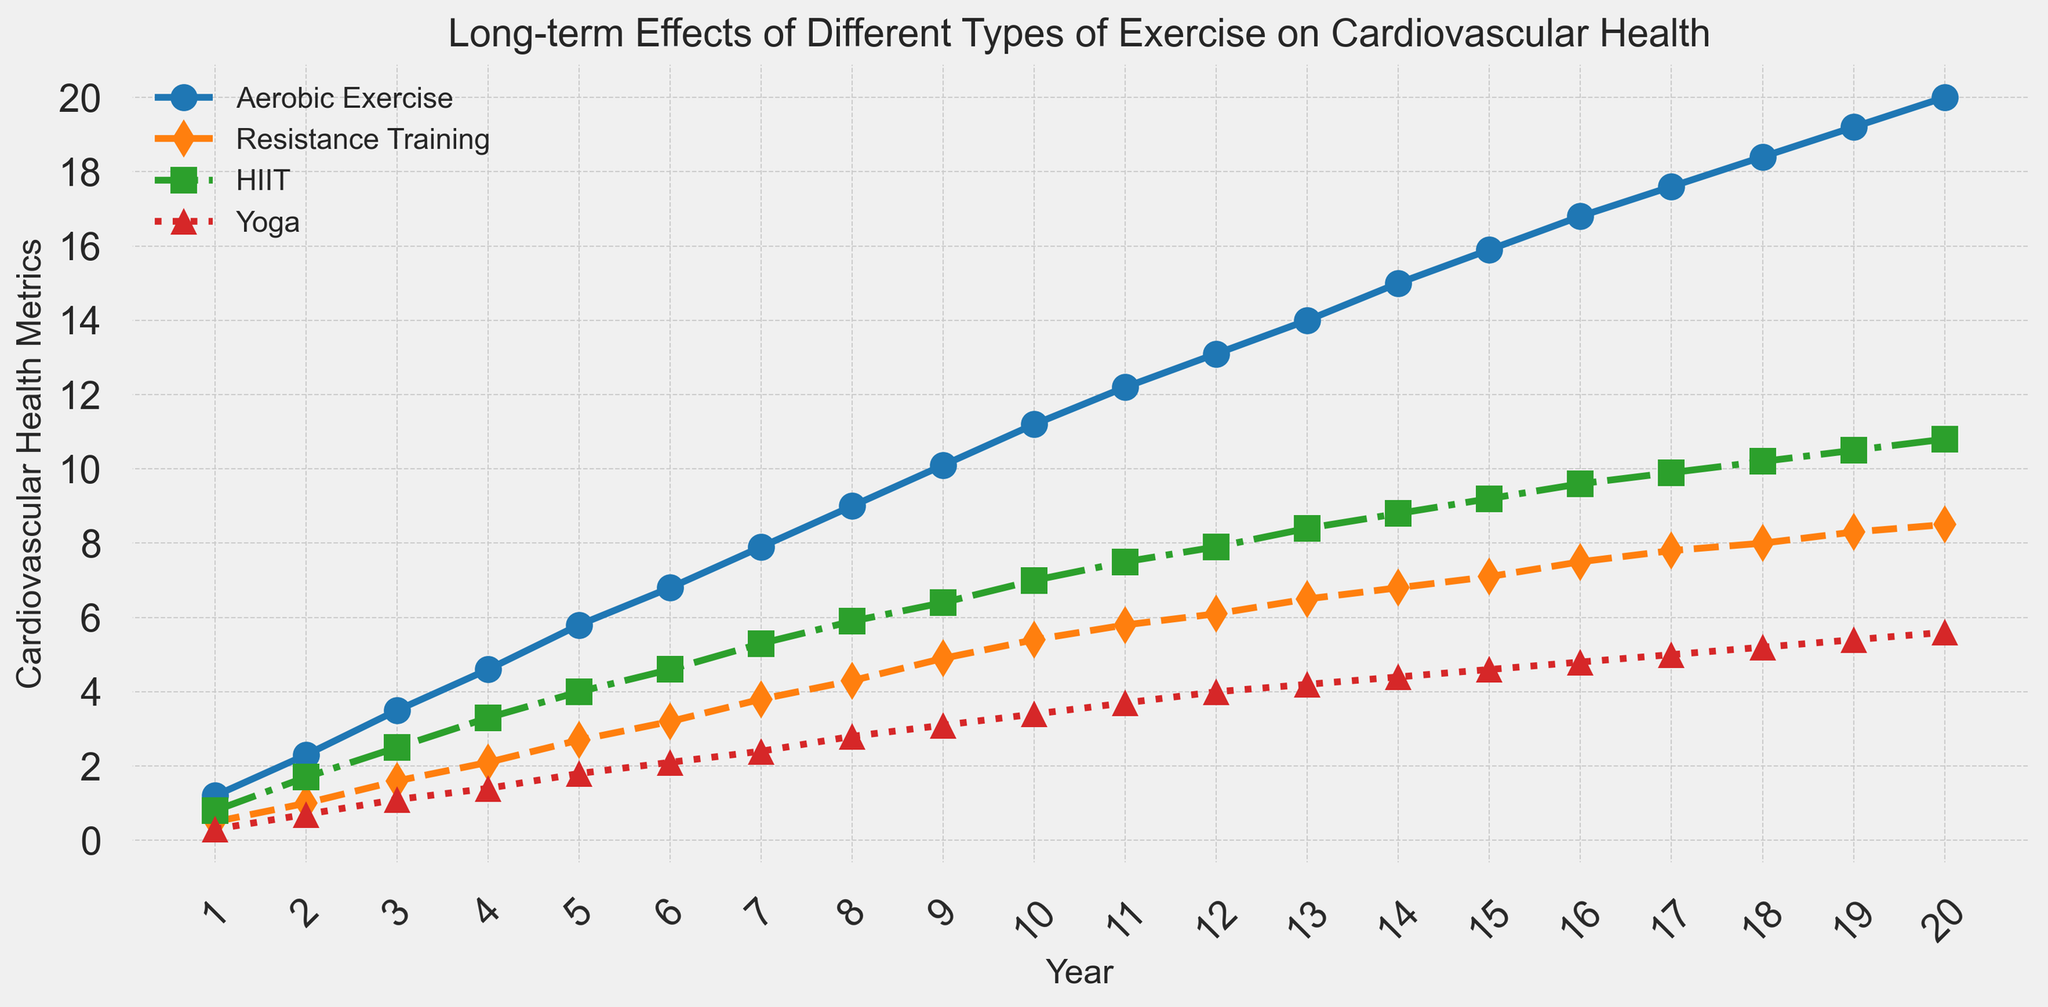Which exercise type shows the greatest improvement in cardiovascular health over the 20 years? Compare the end values of all the exercise types at the 20-year mark. Aerobic Exercise shows 20.0, Resistance Training shows 8.5, HIIT shows 10.8, and Yoga shows 5.6. Hence, Aerobic Exercise shows the greatest improvement.
Answer: Aerobic Exercise How does the cardiovascular health improvement from Year 10 to Year 20 for HIIT compare to that of Yoga? Calculate the differences between Year 20 and Year 10 for both HIIT and Yoga. HIIT improves by 10.8 - 7.0 = 3.8, while Yoga improves by 5.6 - 3.4 = 2.2. Therefore, the improvement for HIIT is greater.
Answer: HIIT improves more Between which years does Resistance Training see the highest rate of improvement in cardiovascular health? To find the highest rate of improvement, calculate the differences year by year for Resistance Training and find the largest increase. The greatest year-to-year increase is from Year 19 to Year 20 (8.5 - 8.3 = 0.2).
Answer: Years 19 to 20 How much more improvement does Aerobic Exercise show compared to HIIT in Year 12? Compare values at Year 12: Aerobic Exercise is 13.1, HIIT is 7.9. The difference is 13.1 - 7.9 = 5.2.
Answer: 5.2 Which type of exercise shows the least improvement after 20 years and what is this value? Review the end values for all exercise types at Year 20. Yoga has the least improvement with a value of 5.6.
Answer: Yoga, 5.6 What color represents HIIT in the chart and how can it be identified? HIIT is represented by the green line with square markers and a dash-dot linestyle.
Answer: Green What trends can be observed regarding the cardiovascular health metrics for Yoga between Year 1 and Year 10? The trend for Yoga shows a gradual and consistent increase year by year: starting at 0.3 and ending at 3.4.
Answer: Gradual increase What is the average improvement in cardiovascular health shown by Resistance Training over the 20-year period? Sum the values of Resistance Training and divide by 20. \( \frac{0.5 + 1.0 + 1.6 + 2.1 + 2.7 + 3.2 + 3.8 + 4.3 + 4.9 + 5.4 + 5.8 + 6.1 + 6.5 + 6.8 + 7.1 + 7.5 + 7.8 + 8.0 + 8.3 + 8.5}{20} = 5.02 \).
Answer: 5.02 